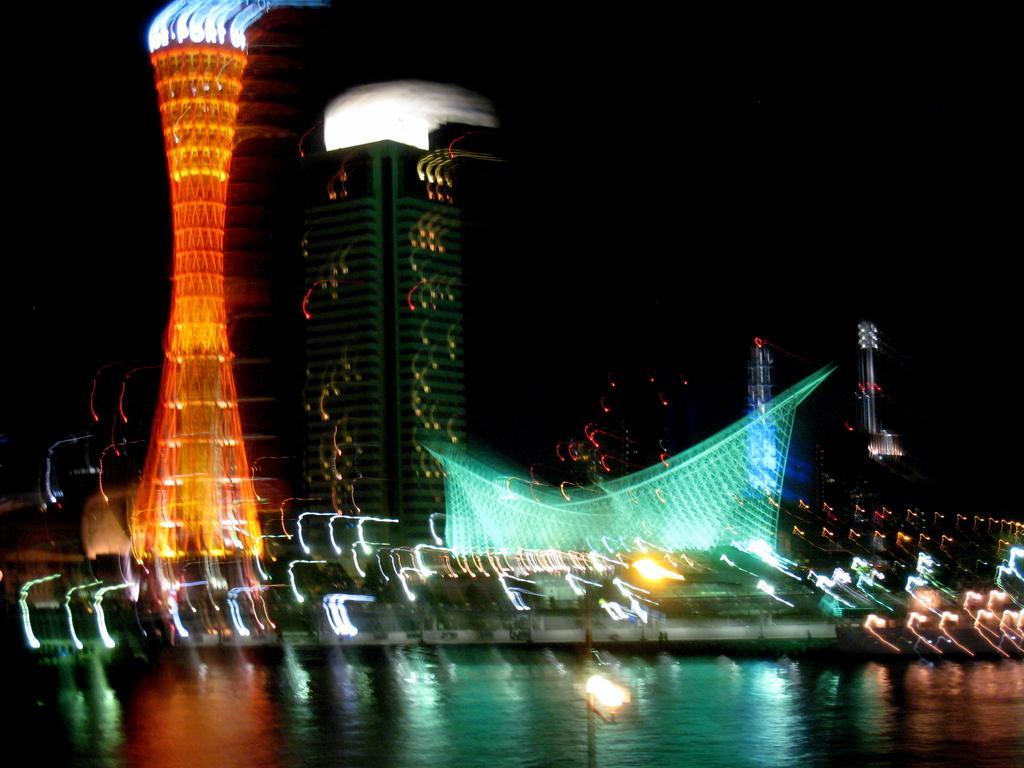Describe this image in one or two sentences. In front of the image there is a lamp post, behind the lamp post there is water, behind the water there are buildings. 